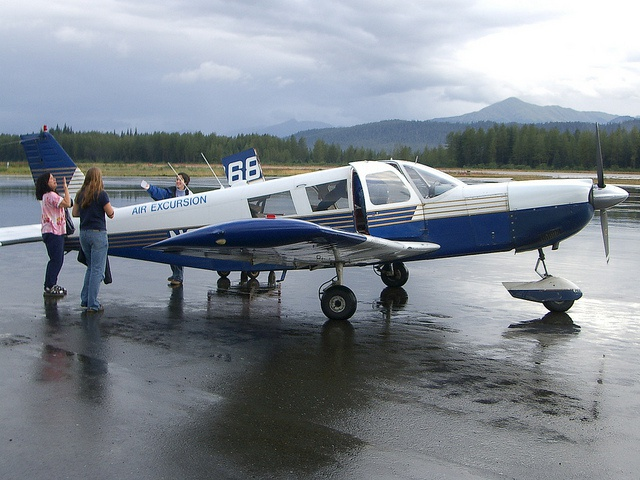Describe the objects in this image and their specific colors. I can see airplane in lavender, lightgray, navy, black, and gray tones, people in lavender, black, blue, gray, and navy tones, people in lavender, black, brown, darkgray, and lightpink tones, and people in lavender, black, navy, gray, and darkblue tones in this image. 